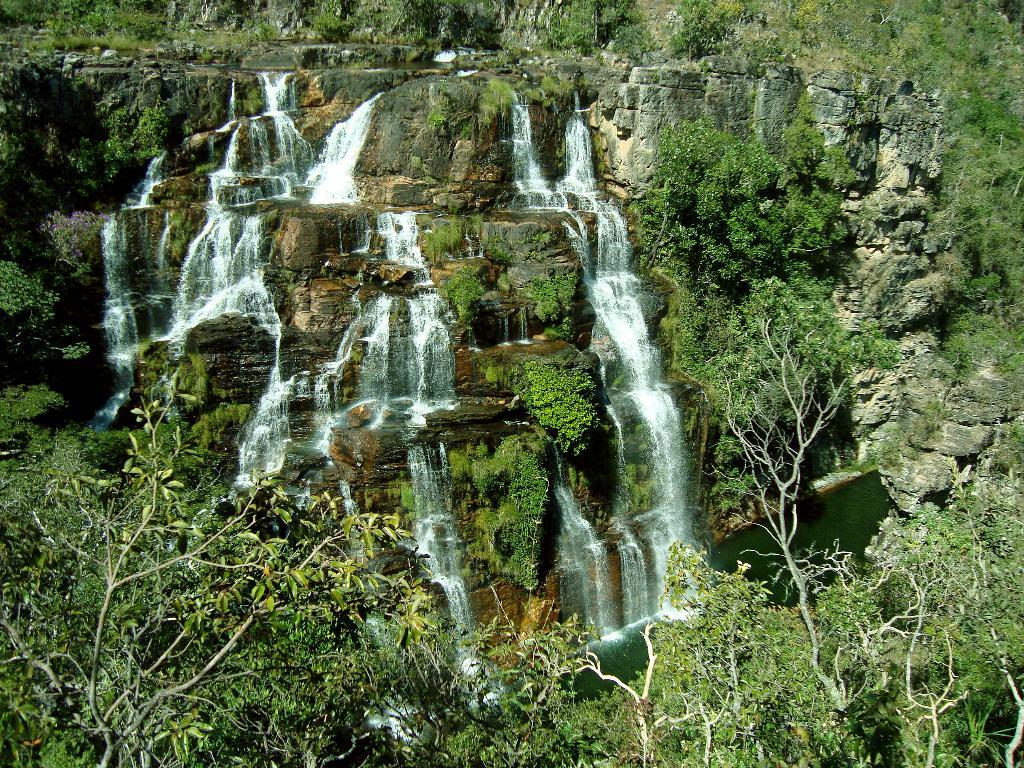What natural feature is the main subject of the image? There is a waterfall in the image. What type of vegetation can be seen in the image? There are trees in the image. What is present at the base of the waterfall? There is water at the bottom of the waterfall. What type of hands can be seen holding the coast in the image? There are no hands or coast present in the image; it features a waterfall and trees. 